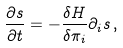<formula> <loc_0><loc_0><loc_500><loc_500>\frac { \partial s } { \partial t } = - \frac { \delta H } { \delta \pi _ { i } } \partial _ { i } s \, ,</formula> 